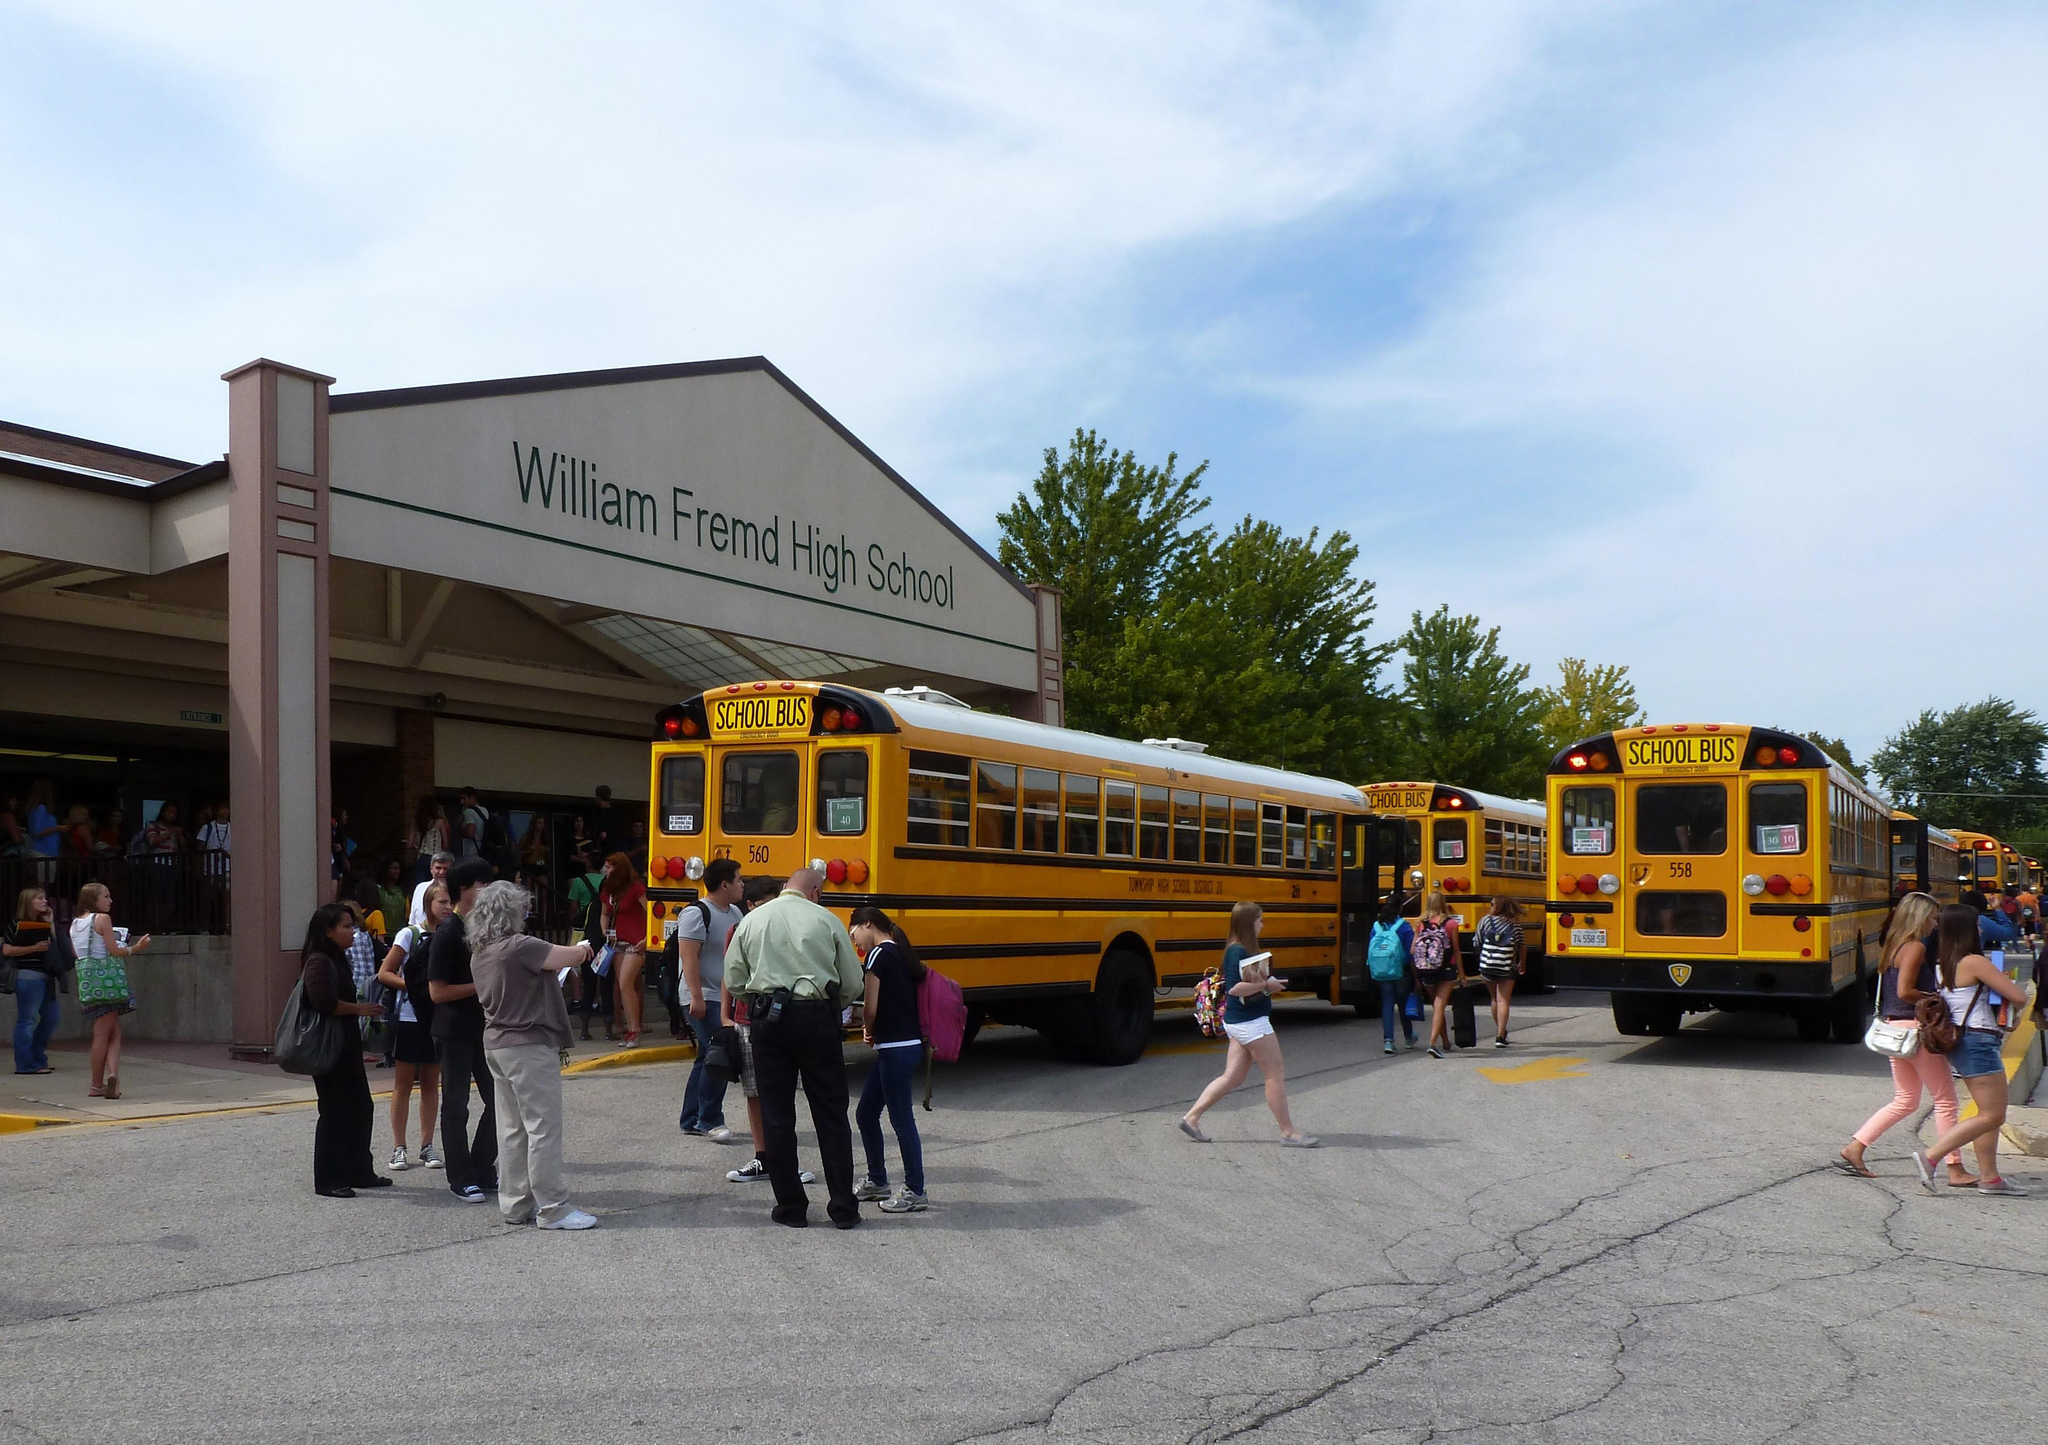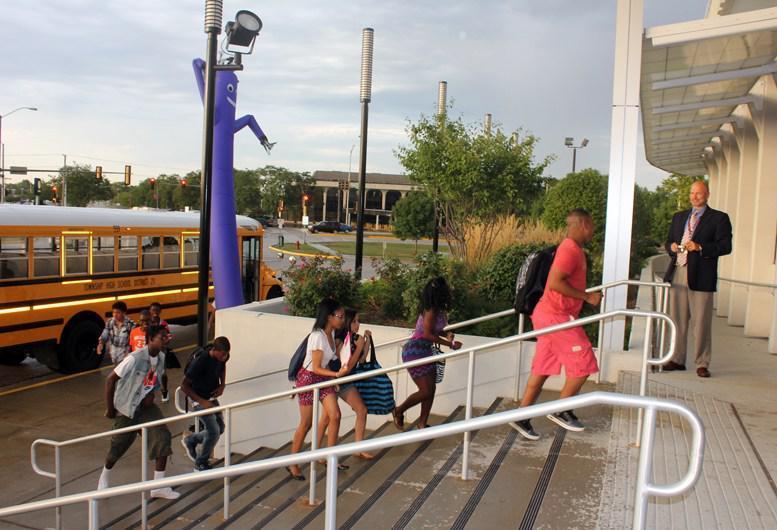The first image is the image on the left, the second image is the image on the right. For the images shown, is this caption "An image shows an open bus door viewed head-on, with steps leading inside and the driver seat facing rightward." true? Answer yes or no. No. 